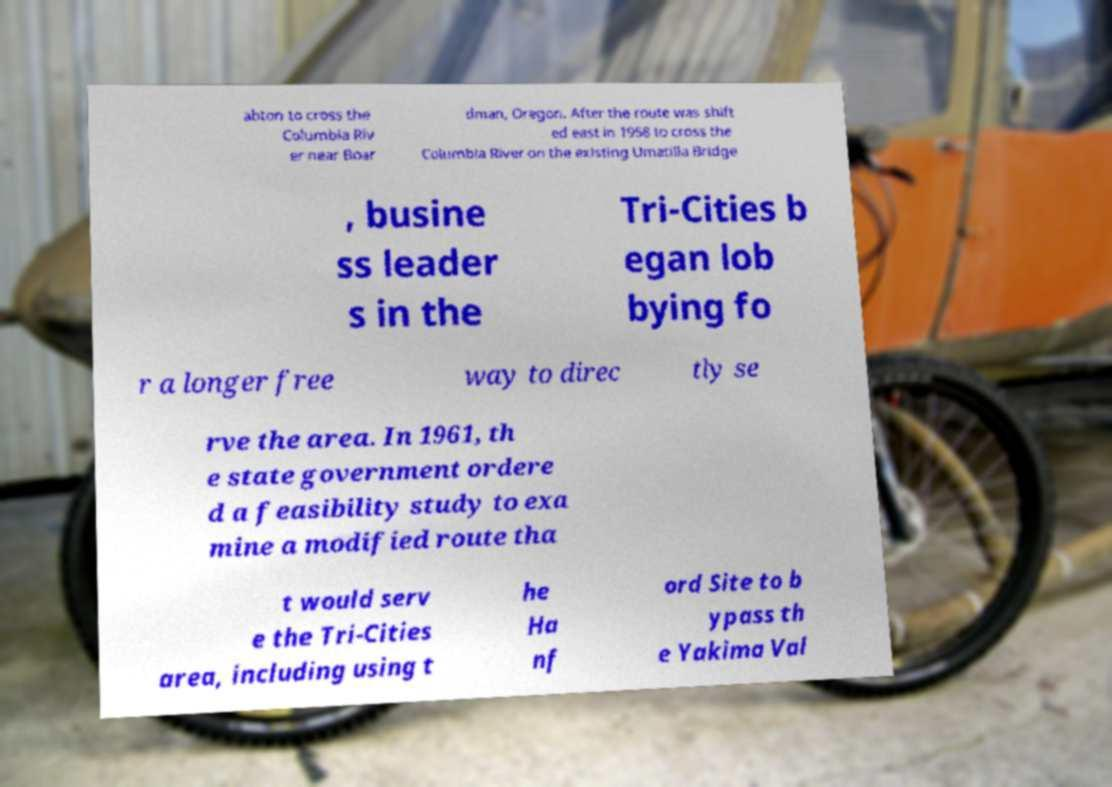What messages or text are displayed in this image? I need them in a readable, typed format. abton to cross the Columbia Riv er near Boar dman, Oregon. After the route was shift ed east in 1958 to cross the Columbia River on the existing Umatilla Bridge , busine ss leader s in the Tri-Cities b egan lob bying fo r a longer free way to direc tly se rve the area. In 1961, th e state government ordere d a feasibility study to exa mine a modified route tha t would serv e the Tri-Cities area, including using t he Ha nf ord Site to b ypass th e Yakima Val 